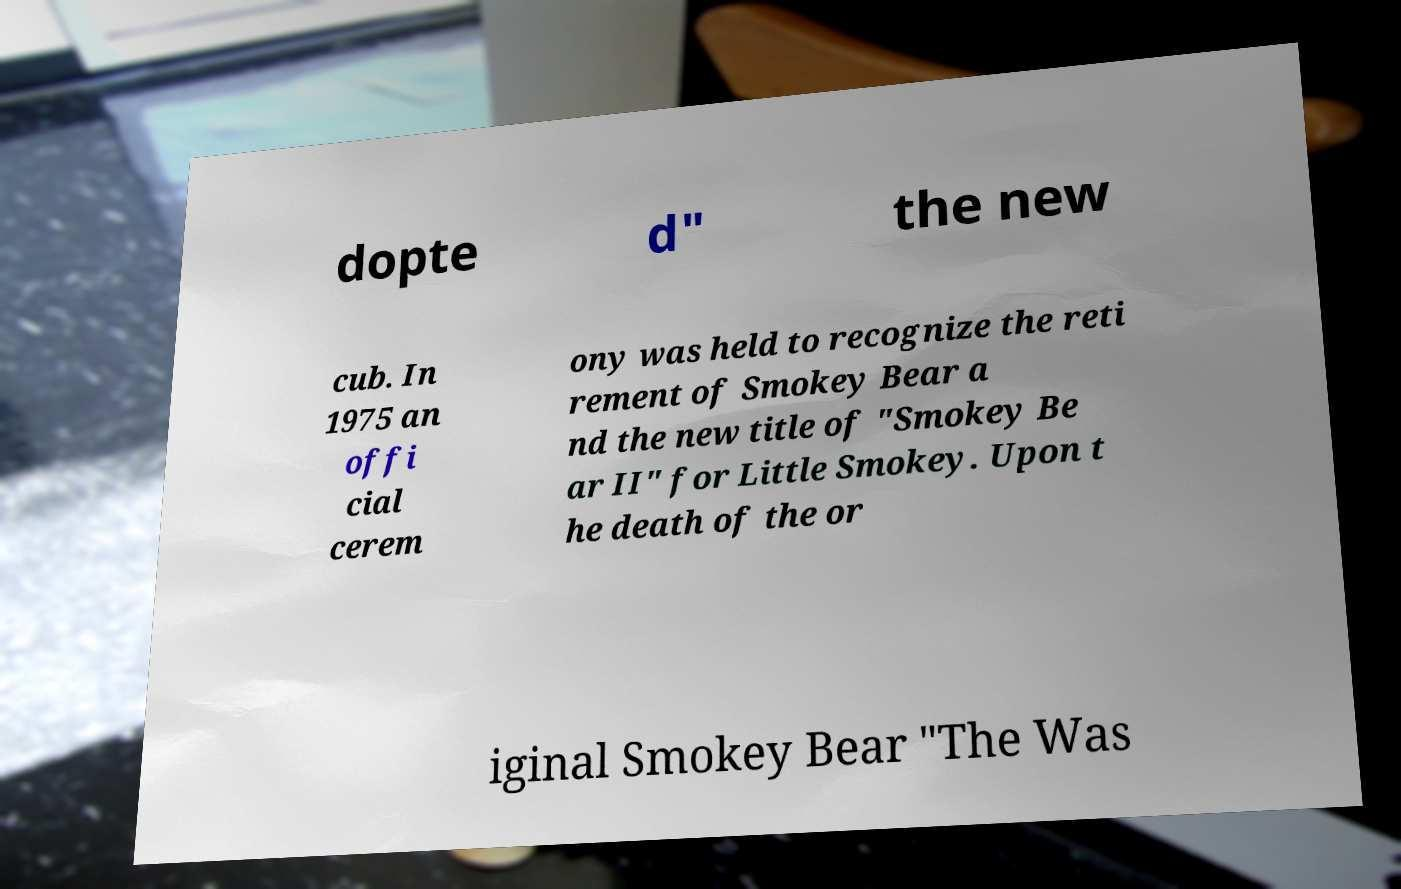There's text embedded in this image that I need extracted. Can you transcribe it verbatim? dopte d" the new cub. In 1975 an offi cial cerem ony was held to recognize the reti rement of Smokey Bear a nd the new title of "Smokey Be ar II" for Little Smokey. Upon t he death of the or iginal Smokey Bear "The Was 